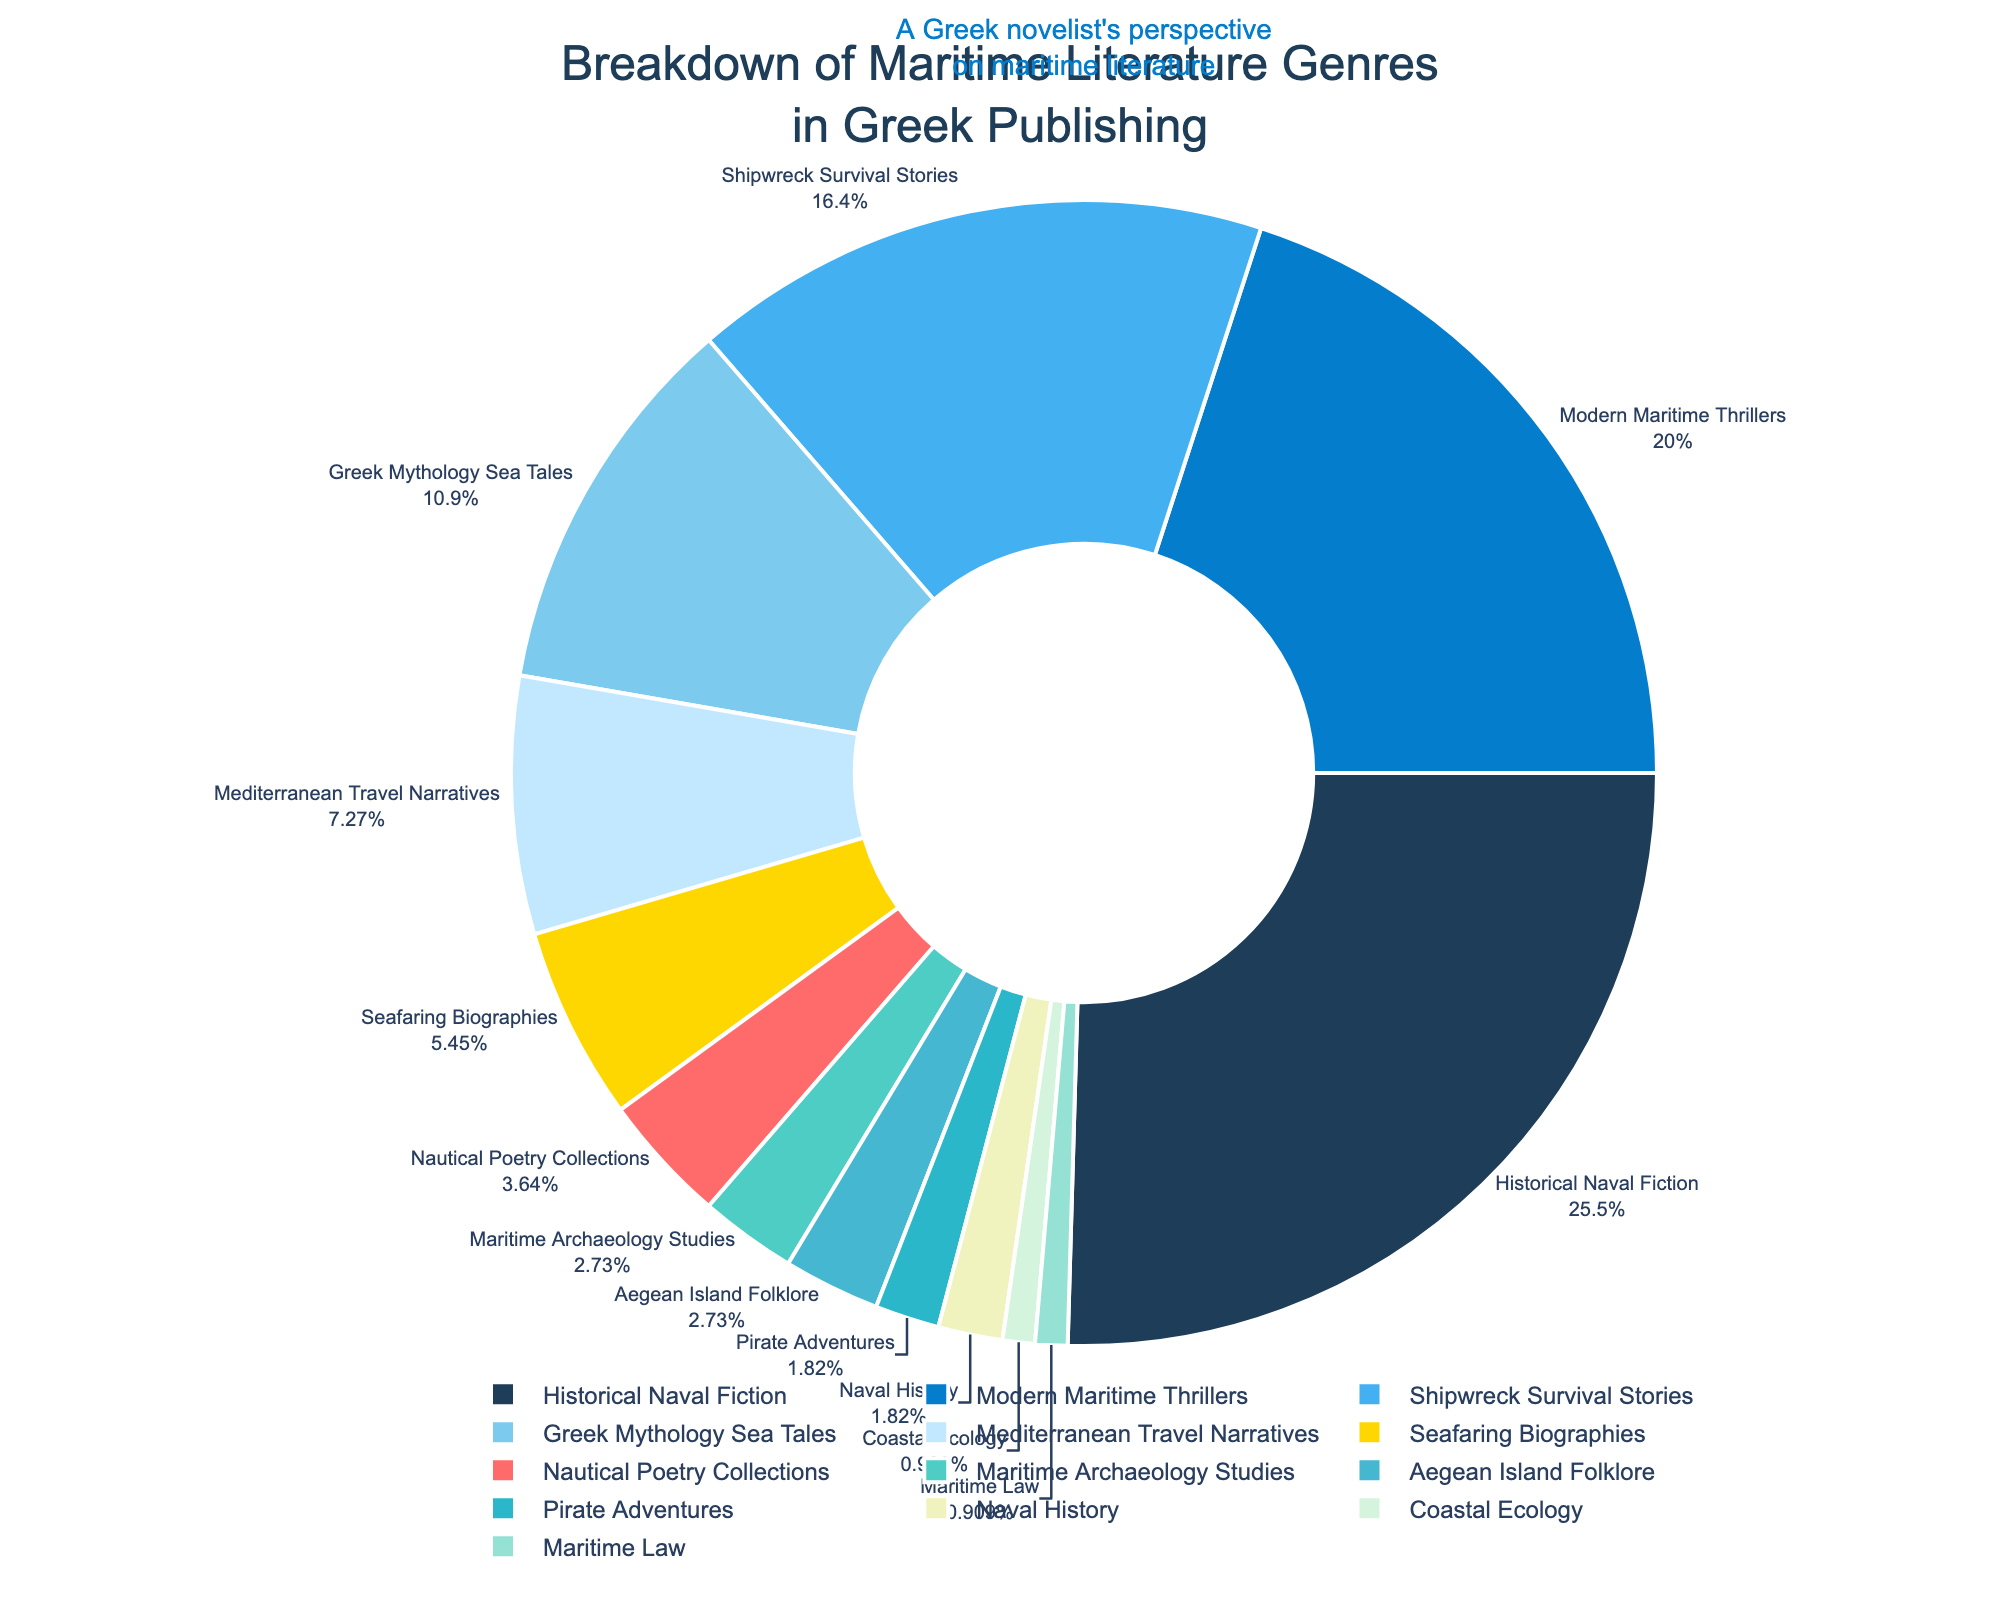What is the genre with the highest percentage in Greek maritime literature? The genre with the highest percentage is visually the largest segment of the pie chart and often placed at the top or prominent position. Here, it’s labeled as "Historical Naval Fiction" with a percentage of 28%.
Answer: Historical Naval Fiction Which genre has a lower percentage: Greek Mythology Sea Tales or Shipwreck Survival Stories? By comparing the sizes of their respective pie segments, the "Greek Mythology Sea Tales" has a percentage of 12%, while "Shipwreck Survival Stories" has 18%. Therefore, "Greek Mythology Sea Tales" has a lower percentage.
Answer: Greek Mythology Sea Tales What percentage of maritime literature genres is contributed by genres with less than 5% each? The genres with less than 5% are "Nautical Poetry Collections" (4%), "Maritime Archaeology Studies" (3%), "Aegean Island Folklore" (3%), "Pirate Adventures" (2%), "Naval History" (2%), "Coastal Ecology" (1%), and "Maritime Law" (1%). Summing these gives 4 + 3 + 3 + 2 + 2 + 1 + 1 = 16%.
Answer: 16% How much greater is the percentage of Historical Naval Fiction compared to Modern Maritime Thrillers? The percentage of "Historical Naval Fiction" is 28%, while "Modern Maritime Thrillers" is 22%. The difference is 28% - 22% = 6%.
Answer: 6% Which genre is represented by the golden color in the pie chart? The golden color in the pie chart represents the segment which corresponds to "Mediterranean Travel Narratives" labeled with 8%.
Answer: Mediterranean Travel Narratives Are the combined percentages of Coastal Ecology and Maritime Law equal to or greater than the percentage of Pirate Adventures? "Coastal Ecology" has 1%, and "Maritime Law" has 1%, so combined they are 1% + 1% = 2%, which is equal to "Pirate Adventures" with 2%.
Answer: Equal What is the sum of percentages for genres that deal with historical content: Historical Naval Fiction and Naval History? "Historical Naval Fiction" is 28% and "Naval History" is 2%, so their total is 28% + 2% = 30%.
Answer: 30% Which genre has the smallest percentage and what is it? The smallest percentages are shared by "Coastal Ecology" and "Maritime Law", each with 1%.
Answer: Coastal Ecology and Maritime Law What are the percentages of the top three maritime literature genres combined? The top three genres are "Historical Naval Fiction" (28%), "Modern Maritime Thrillers" (22%), and "Shipwreck Survival Stories" (18%). Their total is 28% + 22% + 18% = 68%.
Answer: 68% How does the percentage of Seafaring Biographies compare to that of Nautical Poetry Collections? "Seafaring Biographies" has a percentage of 6%, and "Nautical Poetry Collections" has 4%. Comparing the two, "Seafaring Biographies" has a higher percentage by 6% - 4% = 2%.
Answer: Seafaring Biographies is higher by 2% 